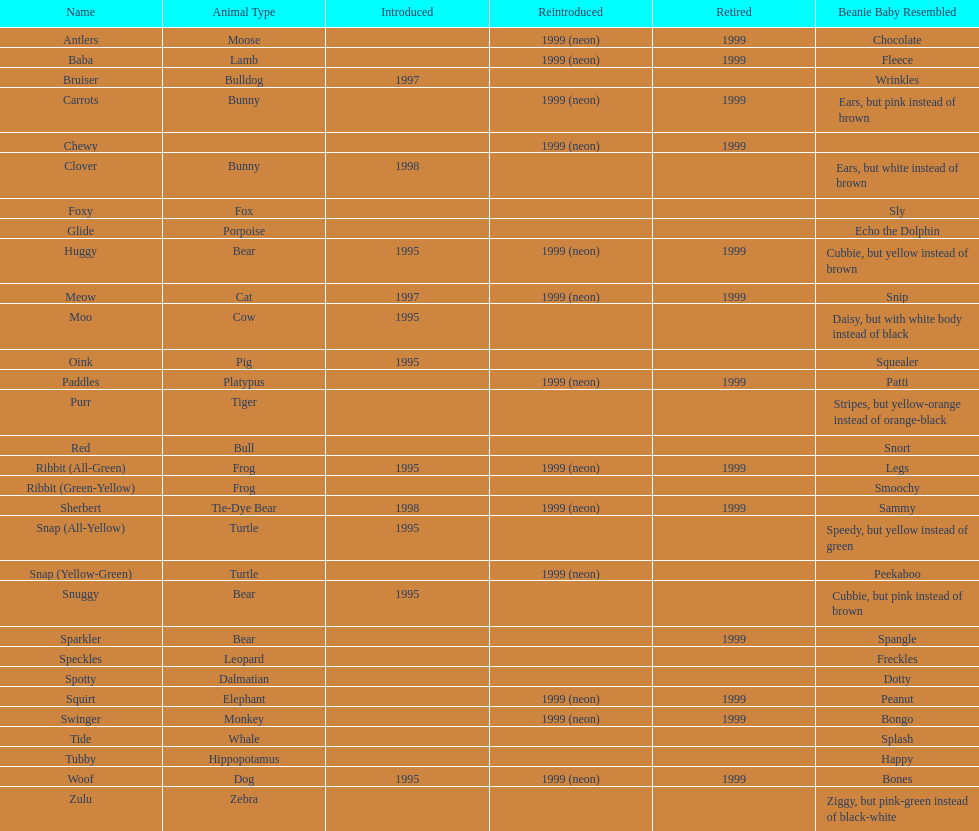How many total pillow pals were both reintroduced and retired in 1999? 12. 